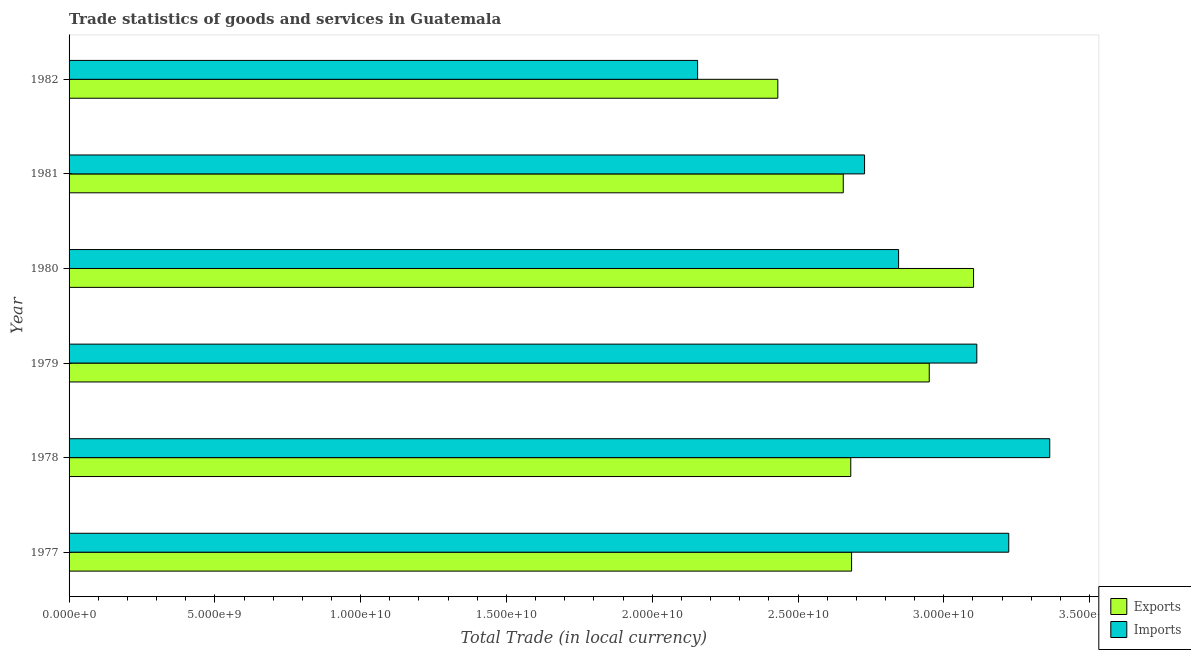Are the number of bars per tick equal to the number of legend labels?
Offer a terse response. Yes. How many bars are there on the 1st tick from the top?
Keep it short and to the point. 2. How many bars are there on the 6th tick from the bottom?
Offer a very short reply. 2. In how many cases, is the number of bars for a given year not equal to the number of legend labels?
Provide a short and direct response. 0. What is the export of goods and services in 1982?
Your response must be concise. 2.43e+1. Across all years, what is the maximum export of goods and services?
Offer a terse response. 3.10e+1. Across all years, what is the minimum export of goods and services?
Make the answer very short. 2.43e+1. In which year was the imports of goods and services maximum?
Provide a succinct answer. 1978. What is the total export of goods and services in the graph?
Your answer should be compact. 1.65e+11. What is the difference between the export of goods and services in 1981 and that in 1982?
Make the answer very short. 2.24e+09. What is the difference between the export of goods and services in 1979 and the imports of goods and services in 1981?
Give a very brief answer. 2.22e+09. What is the average imports of goods and services per year?
Provide a short and direct response. 2.90e+1. In the year 1982, what is the difference between the export of goods and services and imports of goods and services?
Your answer should be compact. 2.75e+09. What is the ratio of the imports of goods and services in 1980 to that in 1981?
Provide a short and direct response. 1.04. Is the export of goods and services in 1979 less than that in 1982?
Offer a very short reply. No. What is the difference between the highest and the second highest imports of goods and services?
Provide a short and direct response. 1.41e+09. What is the difference between the highest and the lowest imports of goods and services?
Ensure brevity in your answer.  1.21e+1. In how many years, is the export of goods and services greater than the average export of goods and services taken over all years?
Your answer should be very brief. 2. Is the sum of the export of goods and services in 1979 and 1982 greater than the maximum imports of goods and services across all years?
Ensure brevity in your answer.  Yes. What does the 2nd bar from the top in 1980 represents?
Provide a succinct answer. Exports. What does the 1st bar from the bottom in 1979 represents?
Your answer should be very brief. Exports. How many bars are there?
Offer a terse response. 12. Are all the bars in the graph horizontal?
Give a very brief answer. Yes. Does the graph contain any zero values?
Your answer should be compact. No. How are the legend labels stacked?
Your response must be concise. Vertical. What is the title of the graph?
Keep it short and to the point. Trade statistics of goods and services in Guatemala. What is the label or title of the X-axis?
Offer a terse response. Total Trade (in local currency). What is the label or title of the Y-axis?
Your answer should be compact. Year. What is the Total Trade (in local currency) in Exports in 1977?
Your response must be concise. 2.68e+1. What is the Total Trade (in local currency) in Imports in 1977?
Offer a very short reply. 3.22e+1. What is the Total Trade (in local currency) in Exports in 1978?
Provide a short and direct response. 2.68e+1. What is the Total Trade (in local currency) in Imports in 1978?
Offer a terse response. 3.36e+1. What is the Total Trade (in local currency) of Exports in 1979?
Offer a very short reply. 2.95e+1. What is the Total Trade (in local currency) of Imports in 1979?
Provide a short and direct response. 3.11e+1. What is the Total Trade (in local currency) of Exports in 1980?
Give a very brief answer. 3.10e+1. What is the Total Trade (in local currency) of Imports in 1980?
Offer a very short reply. 2.84e+1. What is the Total Trade (in local currency) in Exports in 1981?
Give a very brief answer. 2.66e+1. What is the Total Trade (in local currency) in Imports in 1981?
Offer a very short reply. 2.73e+1. What is the Total Trade (in local currency) in Exports in 1982?
Your answer should be very brief. 2.43e+1. What is the Total Trade (in local currency) of Imports in 1982?
Your answer should be very brief. 2.16e+1. Across all years, what is the maximum Total Trade (in local currency) in Exports?
Make the answer very short. 3.10e+1. Across all years, what is the maximum Total Trade (in local currency) of Imports?
Offer a terse response. 3.36e+1. Across all years, what is the minimum Total Trade (in local currency) in Exports?
Give a very brief answer. 2.43e+1. Across all years, what is the minimum Total Trade (in local currency) in Imports?
Your answer should be very brief. 2.16e+1. What is the total Total Trade (in local currency) in Exports in the graph?
Ensure brevity in your answer.  1.65e+11. What is the total Total Trade (in local currency) of Imports in the graph?
Your answer should be compact. 1.74e+11. What is the difference between the Total Trade (in local currency) in Exports in 1977 and that in 1978?
Provide a short and direct response. 2.86e+07. What is the difference between the Total Trade (in local currency) of Imports in 1977 and that in 1978?
Offer a very short reply. -1.41e+09. What is the difference between the Total Trade (in local currency) in Exports in 1977 and that in 1979?
Your answer should be compact. -2.66e+09. What is the difference between the Total Trade (in local currency) in Imports in 1977 and that in 1979?
Keep it short and to the point. 1.10e+09. What is the difference between the Total Trade (in local currency) of Exports in 1977 and that in 1980?
Give a very brief answer. -4.18e+09. What is the difference between the Total Trade (in local currency) of Imports in 1977 and that in 1980?
Keep it short and to the point. 3.78e+09. What is the difference between the Total Trade (in local currency) of Exports in 1977 and that in 1981?
Make the answer very short. 2.86e+08. What is the difference between the Total Trade (in local currency) of Imports in 1977 and that in 1981?
Your response must be concise. 4.95e+09. What is the difference between the Total Trade (in local currency) of Exports in 1977 and that in 1982?
Your response must be concise. 2.53e+09. What is the difference between the Total Trade (in local currency) in Imports in 1977 and that in 1982?
Give a very brief answer. 1.07e+1. What is the difference between the Total Trade (in local currency) in Exports in 1978 and that in 1979?
Ensure brevity in your answer.  -2.69e+09. What is the difference between the Total Trade (in local currency) in Imports in 1978 and that in 1979?
Provide a short and direct response. 2.50e+09. What is the difference between the Total Trade (in local currency) of Exports in 1978 and that in 1980?
Your answer should be compact. -4.21e+09. What is the difference between the Total Trade (in local currency) in Imports in 1978 and that in 1980?
Provide a succinct answer. 5.18e+09. What is the difference between the Total Trade (in local currency) in Exports in 1978 and that in 1981?
Make the answer very short. 2.57e+08. What is the difference between the Total Trade (in local currency) of Imports in 1978 and that in 1981?
Keep it short and to the point. 6.35e+09. What is the difference between the Total Trade (in local currency) of Exports in 1978 and that in 1982?
Ensure brevity in your answer.  2.50e+09. What is the difference between the Total Trade (in local currency) of Imports in 1978 and that in 1982?
Make the answer very short. 1.21e+1. What is the difference between the Total Trade (in local currency) in Exports in 1979 and that in 1980?
Make the answer very short. -1.52e+09. What is the difference between the Total Trade (in local currency) in Imports in 1979 and that in 1980?
Give a very brief answer. 2.68e+09. What is the difference between the Total Trade (in local currency) of Exports in 1979 and that in 1981?
Offer a very short reply. 2.95e+09. What is the difference between the Total Trade (in local currency) in Imports in 1979 and that in 1981?
Your answer should be very brief. 3.85e+09. What is the difference between the Total Trade (in local currency) in Exports in 1979 and that in 1982?
Make the answer very short. 5.19e+09. What is the difference between the Total Trade (in local currency) in Imports in 1979 and that in 1982?
Ensure brevity in your answer.  9.58e+09. What is the difference between the Total Trade (in local currency) in Exports in 1980 and that in 1981?
Offer a very short reply. 4.47e+09. What is the difference between the Total Trade (in local currency) in Imports in 1980 and that in 1981?
Provide a short and direct response. 1.17e+09. What is the difference between the Total Trade (in local currency) of Exports in 1980 and that in 1982?
Your response must be concise. 6.71e+09. What is the difference between the Total Trade (in local currency) of Imports in 1980 and that in 1982?
Your answer should be very brief. 6.89e+09. What is the difference between the Total Trade (in local currency) of Exports in 1981 and that in 1982?
Ensure brevity in your answer.  2.24e+09. What is the difference between the Total Trade (in local currency) of Imports in 1981 and that in 1982?
Offer a terse response. 5.73e+09. What is the difference between the Total Trade (in local currency) of Exports in 1977 and the Total Trade (in local currency) of Imports in 1978?
Give a very brief answer. -6.80e+09. What is the difference between the Total Trade (in local currency) in Exports in 1977 and the Total Trade (in local currency) in Imports in 1979?
Make the answer very short. -4.29e+09. What is the difference between the Total Trade (in local currency) of Exports in 1977 and the Total Trade (in local currency) of Imports in 1980?
Your answer should be very brief. -1.61e+09. What is the difference between the Total Trade (in local currency) in Exports in 1977 and the Total Trade (in local currency) in Imports in 1981?
Your answer should be very brief. -4.45e+08. What is the difference between the Total Trade (in local currency) in Exports in 1977 and the Total Trade (in local currency) in Imports in 1982?
Make the answer very short. 5.28e+09. What is the difference between the Total Trade (in local currency) in Exports in 1978 and the Total Trade (in local currency) in Imports in 1979?
Your answer should be compact. -4.32e+09. What is the difference between the Total Trade (in local currency) in Exports in 1978 and the Total Trade (in local currency) in Imports in 1980?
Ensure brevity in your answer.  -1.64e+09. What is the difference between the Total Trade (in local currency) of Exports in 1978 and the Total Trade (in local currency) of Imports in 1981?
Give a very brief answer. -4.73e+08. What is the difference between the Total Trade (in local currency) in Exports in 1978 and the Total Trade (in local currency) in Imports in 1982?
Offer a very short reply. 5.25e+09. What is the difference between the Total Trade (in local currency) of Exports in 1979 and the Total Trade (in local currency) of Imports in 1980?
Give a very brief answer. 1.05e+09. What is the difference between the Total Trade (in local currency) of Exports in 1979 and the Total Trade (in local currency) of Imports in 1981?
Offer a terse response. 2.22e+09. What is the difference between the Total Trade (in local currency) in Exports in 1979 and the Total Trade (in local currency) in Imports in 1982?
Offer a very short reply. 7.94e+09. What is the difference between the Total Trade (in local currency) of Exports in 1980 and the Total Trade (in local currency) of Imports in 1981?
Keep it short and to the point. 3.74e+09. What is the difference between the Total Trade (in local currency) in Exports in 1980 and the Total Trade (in local currency) in Imports in 1982?
Give a very brief answer. 9.46e+09. What is the difference between the Total Trade (in local currency) in Exports in 1981 and the Total Trade (in local currency) in Imports in 1982?
Your answer should be compact. 5.00e+09. What is the average Total Trade (in local currency) of Exports per year?
Make the answer very short. 2.75e+1. What is the average Total Trade (in local currency) of Imports per year?
Offer a very short reply. 2.90e+1. In the year 1977, what is the difference between the Total Trade (in local currency) in Exports and Total Trade (in local currency) in Imports?
Offer a very short reply. -5.39e+09. In the year 1978, what is the difference between the Total Trade (in local currency) in Exports and Total Trade (in local currency) in Imports?
Your answer should be very brief. -6.82e+09. In the year 1979, what is the difference between the Total Trade (in local currency) of Exports and Total Trade (in local currency) of Imports?
Your answer should be compact. -1.63e+09. In the year 1980, what is the difference between the Total Trade (in local currency) in Exports and Total Trade (in local currency) in Imports?
Offer a very short reply. 2.57e+09. In the year 1981, what is the difference between the Total Trade (in local currency) in Exports and Total Trade (in local currency) in Imports?
Offer a very short reply. -7.30e+08. In the year 1982, what is the difference between the Total Trade (in local currency) in Exports and Total Trade (in local currency) in Imports?
Make the answer very short. 2.75e+09. What is the ratio of the Total Trade (in local currency) of Imports in 1977 to that in 1978?
Make the answer very short. 0.96. What is the ratio of the Total Trade (in local currency) of Exports in 1977 to that in 1979?
Give a very brief answer. 0.91. What is the ratio of the Total Trade (in local currency) of Imports in 1977 to that in 1979?
Your response must be concise. 1.04. What is the ratio of the Total Trade (in local currency) of Exports in 1977 to that in 1980?
Ensure brevity in your answer.  0.87. What is the ratio of the Total Trade (in local currency) in Imports in 1977 to that in 1980?
Give a very brief answer. 1.13. What is the ratio of the Total Trade (in local currency) of Exports in 1977 to that in 1981?
Provide a short and direct response. 1.01. What is the ratio of the Total Trade (in local currency) of Imports in 1977 to that in 1981?
Provide a succinct answer. 1.18. What is the ratio of the Total Trade (in local currency) of Exports in 1977 to that in 1982?
Give a very brief answer. 1.1. What is the ratio of the Total Trade (in local currency) in Imports in 1977 to that in 1982?
Offer a terse response. 1.5. What is the ratio of the Total Trade (in local currency) in Exports in 1978 to that in 1979?
Offer a very short reply. 0.91. What is the ratio of the Total Trade (in local currency) in Imports in 1978 to that in 1979?
Ensure brevity in your answer.  1.08. What is the ratio of the Total Trade (in local currency) of Exports in 1978 to that in 1980?
Keep it short and to the point. 0.86. What is the ratio of the Total Trade (in local currency) of Imports in 1978 to that in 1980?
Provide a short and direct response. 1.18. What is the ratio of the Total Trade (in local currency) in Exports in 1978 to that in 1981?
Your answer should be compact. 1.01. What is the ratio of the Total Trade (in local currency) in Imports in 1978 to that in 1981?
Your answer should be very brief. 1.23. What is the ratio of the Total Trade (in local currency) in Exports in 1978 to that in 1982?
Give a very brief answer. 1.1. What is the ratio of the Total Trade (in local currency) in Imports in 1978 to that in 1982?
Provide a short and direct response. 1.56. What is the ratio of the Total Trade (in local currency) of Exports in 1979 to that in 1980?
Offer a terse response. 0.95. What is the ratio of the Total Trade (in local currency) in Imports in 1979 to that in 1980?
Provide a succinct answer. 1.09. What is the ratio of the Total Trade (in local currency) of Imports in 1979 to that in 1981?
Give a very brief answer. 1.14. What is the ratio of the Total Trade (in local currency) in Exports in 1979 to that in 1982?
Keep it short and to the point. 1.21. What is the ratio of the Total Trade (in local currency) in Imports in 1979 to that in 1982?
Your answer should be very brief. 1.44. What is the ratio of the Total Trade (in local currency) of Exports in 1980 to that in 1981?
Make the answer very short. 1.17. What is the ratio of the Total Trade (in local currency) in Imports in 1980 to that in 1981?
Give a very brief answer. 1.04. What is the ratio of the Total Trade (in local currency) in Exports in 1980 to that in 1982?
Your answer should be compact. 1.28. What is the ratio of the Total Trade (in local currency) in Imports in 1980 to that in 1982?
Keep it short and to the point. 1.32. What is the ratio of the Total Trade (in local currency) in Exports in 1981 to that in 1982?
Make the answer very short. 1.09. What is the ratio of the Total Trade (in local currency) of Imports in 1981 to that in 1982?
Make the answer very short. 1.27. What is the difference between the highest and the second highest Total Trade (in local currency) in Exports?
Offer a very short reply. 1.52e+09. What is the difference between the highest and the second highest Total Trade (in local currency) in Imports?
Make the answer very short. 1.41e+09. What is the difference between the highest and the lowest Total Trade (in local currency) of Exports?
Keep it short and to the point. 6.71e+09. What is the difference between the highest and the lowest Total Trade (in local currency) in Imports?
Offer a very short reply. 1.21e+1. 